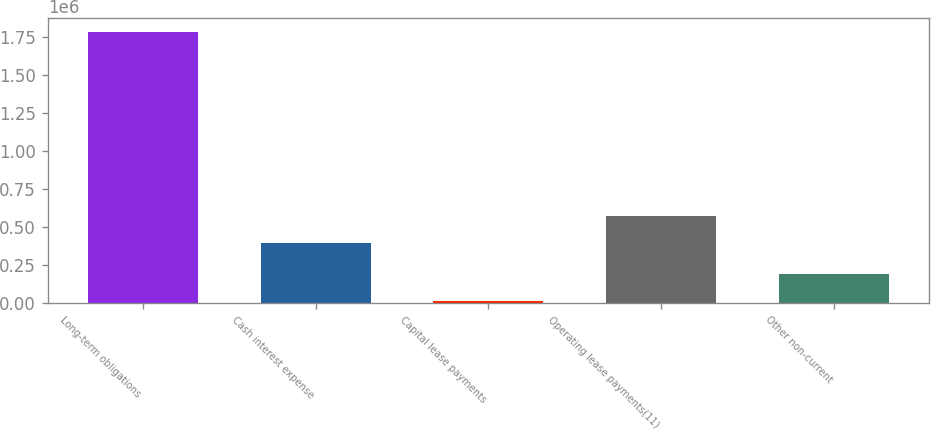<chart> <loc_0><loc_0><loc_500><loc_500><bar_chart><fcel>Long-term obligations<fcel>Cash interest expense<fcel>Capital lease payments<fcel>Operating lease payments(11)<fcel>Other non-current<nl><fcel>1.78745e+06<fcel>399000<fcel>12456<fcel>576500<fcel>189956<nl></chart> 